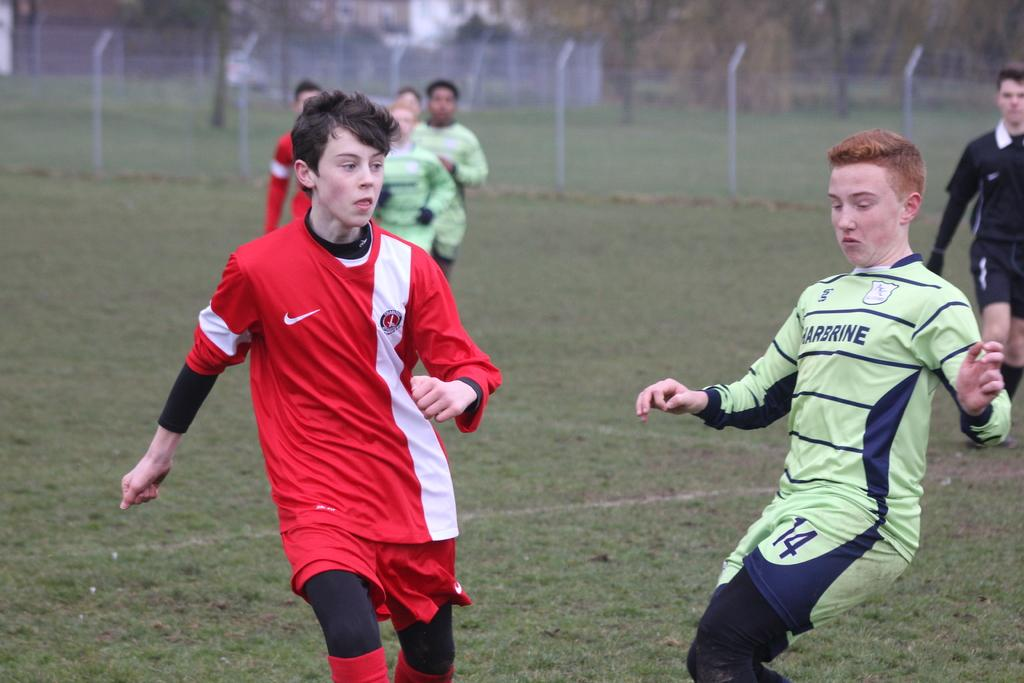<image>
Relay a brief, clear account of the picture shown. The player in the green and navy outfit has the number 14 on his shorts. 